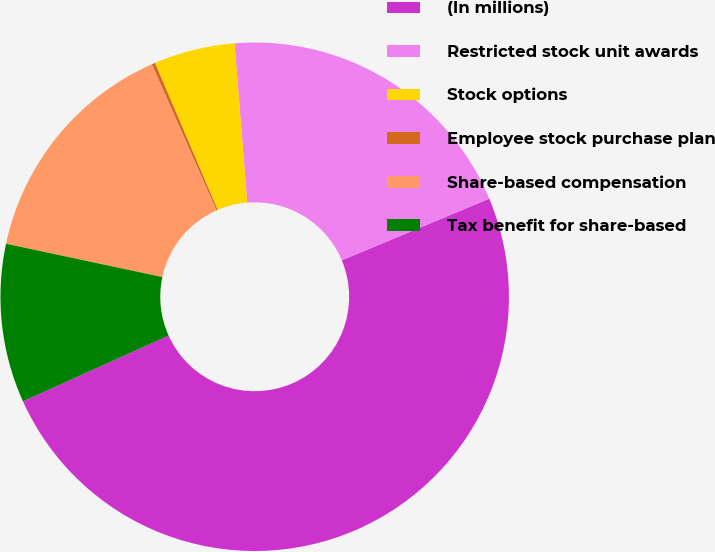<chart> <loc_0><loc_0><loc_500><loc_500><pie_chart><fcel>(In millions)<fcel>Restricted stock unit awards<fcel>Stock options<fcel>Employee stock purchase plan<fcel>Share-based compensation<fcel>Tax benefit for share-based<nl><fcel>49.56%<fcel>19.96%<fcel>5.15%<fcel>0.22%<fcel>15.02%<fcel>10.09%<nl></chart> 